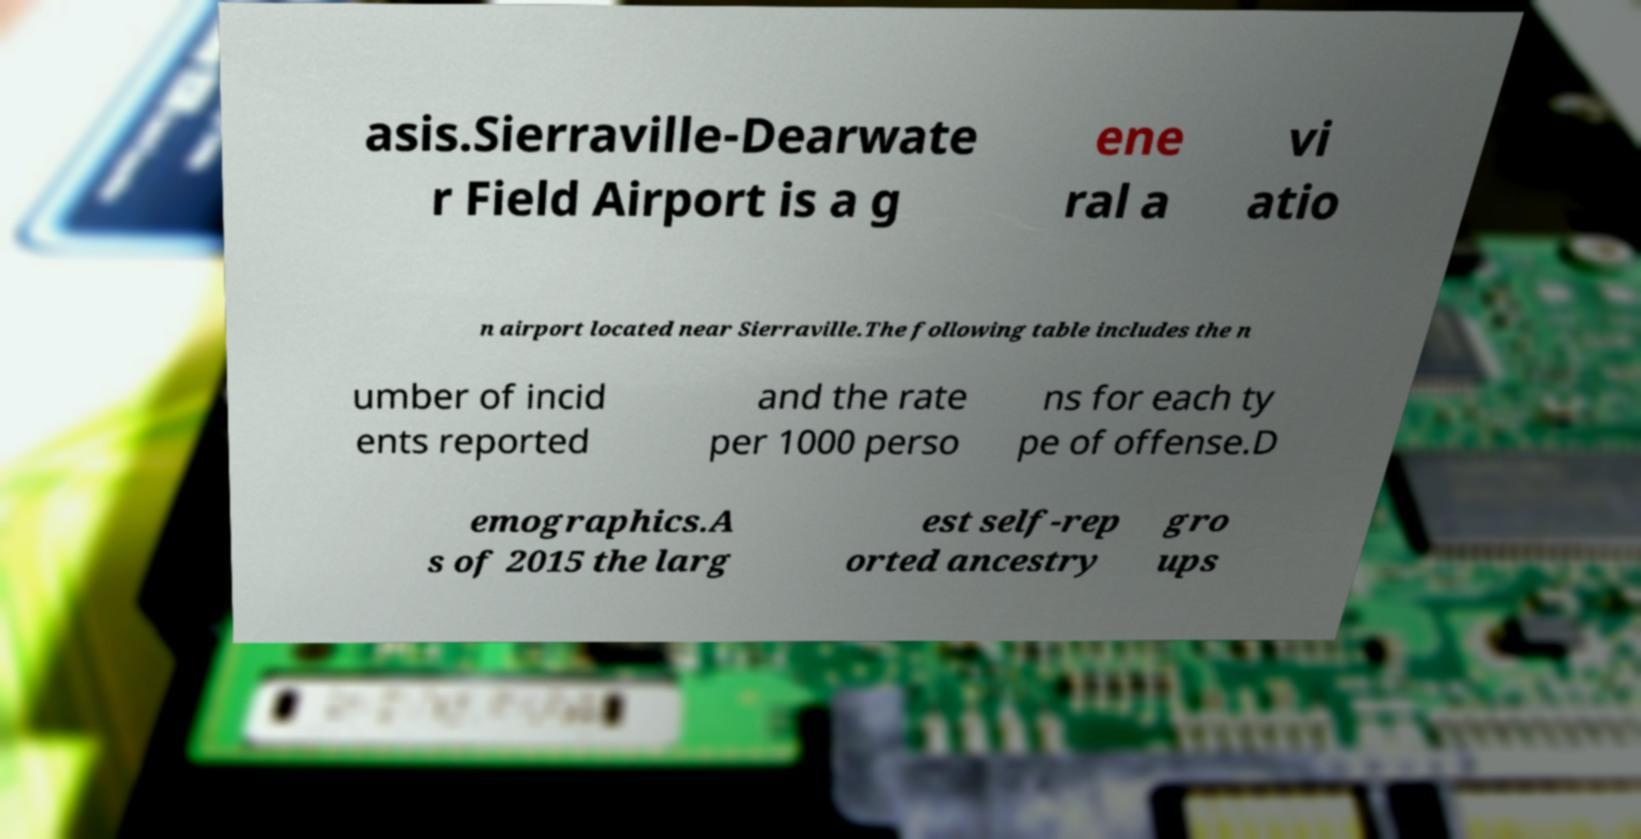Could you assist in decoding the text presented in this image and type it out clearly? asis.Sierraville-Dearwate r Field Airport is a g ene ral a vi atio n airport located near Sierraville.The following table includes the n umber of incid ents reported and the rate per 1000 perso ns for each ty pe of offense.D emographics.A s of 2015 the larg est self-rep orted ancestry gro ups 